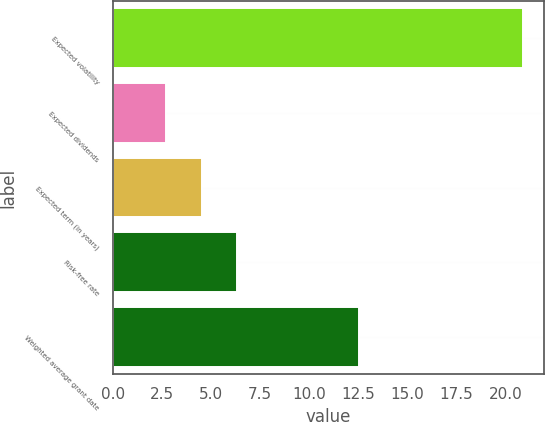Convert chart to OTSL. <chart><loc_0><loc_0><loc_500><loc_500><bar_chart><fcel>Expected volatility<fcel>Expected dividends<fcel>Expected term (in years)<fcel>Risk-free rate<fcel>Weighted average grant date<nl><fcel>20.92<fcel>2.7<fcel>4.52<fcel>6.34<fcel>12.52<nl></chart> 